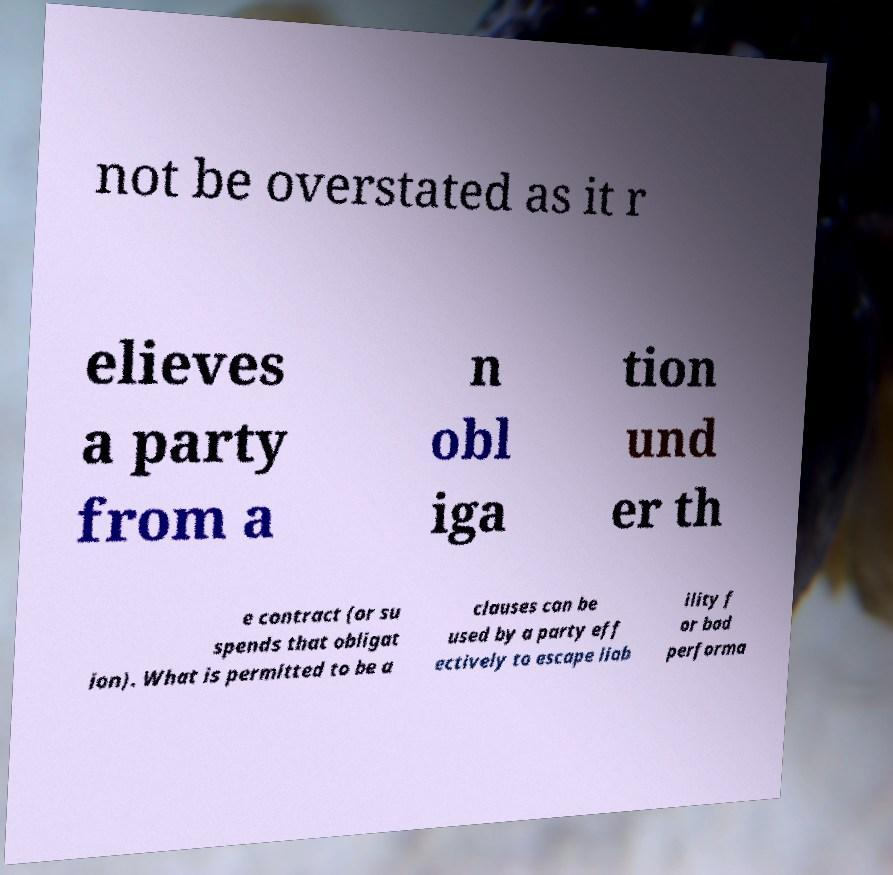Could you extract and type out the text from this image? not be overstated as it r elieves a party from a n obl iga tion und er th e contract (or su spends that obligat ion). What is permitted to be a clauses can be used by a party eff ectively to escape liab ility f or bad performa 